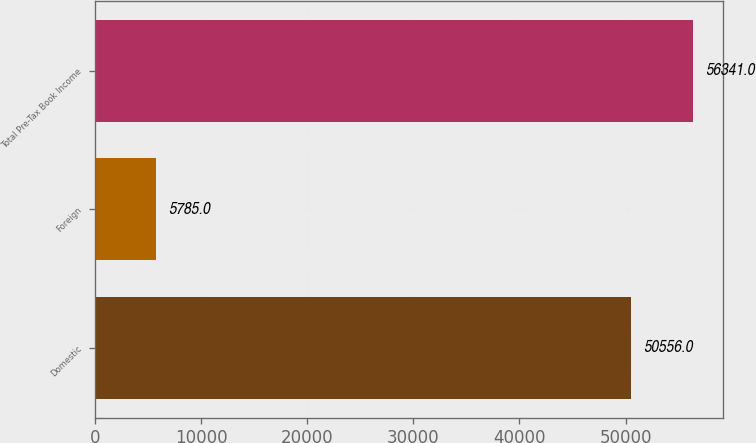Convert chart. <chart><loc_0><loc_0><loc_500><loc_500><bar_chart><fcel>Domestic<fcel>Foreign<fcel>Total Pre-Tax Book Income<nl><fcel>50556<fcel>5785<fcel>56341<nl></chart> 